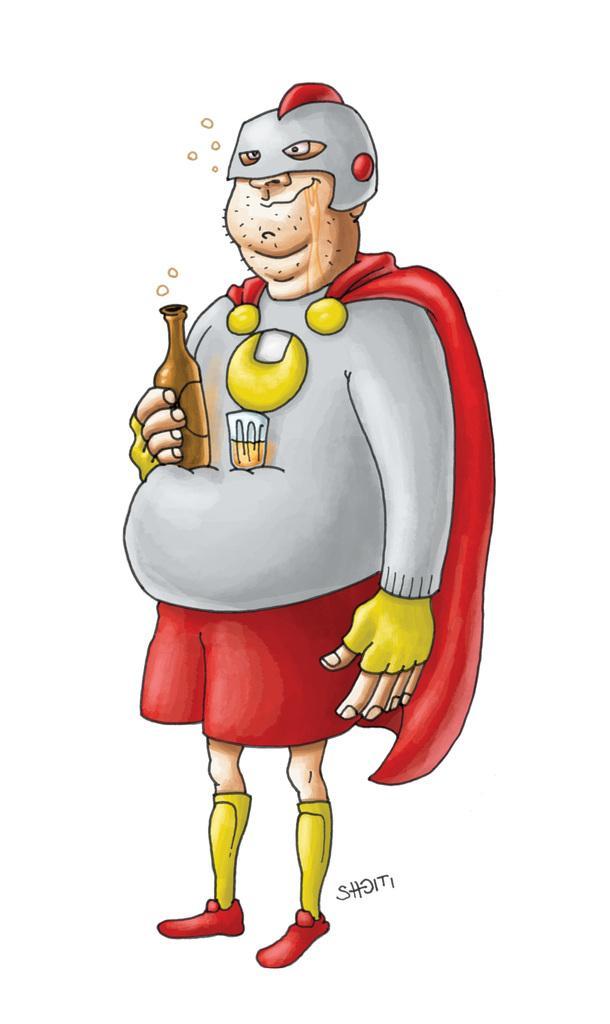How would you summarize this image in a sentence or two? In the center of the image there is a depiction of a person holding a bottle. 